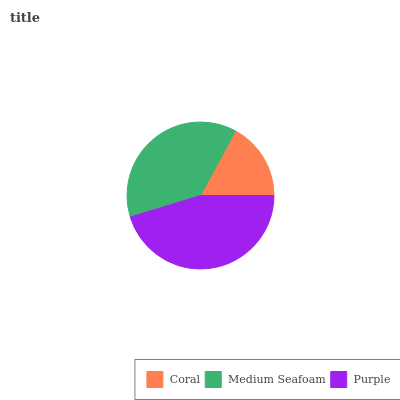Is Coral the minimum?
Answer yes or no. Yes. Is Purple the maximum?
Answer yes or no. Yes. Is Medium Seafoam the minimum?
Answer yes or no. No. Is Medium Seafoam the maximum?
Answer yes or no. No. Is Medium Seafoam greater than Coral?
Answer yes or no. Yes. Is Coral less than Medium Seafoam?
Answer yes or no. Yes. Is Coral greater than Medium Seafoam?
Answer yes or no. No. Is Medium Seafoam less than Coral?
Answer yes or no. No. Is Medium Seafoam the high median?
Answer yes or no. Yes. Is Medium Seafoam the low median?
Answer yes or no. Yes. Is Coral the high median?
Answer yes or no. No. Is Purple the low median?
Answer yes or no. No. 